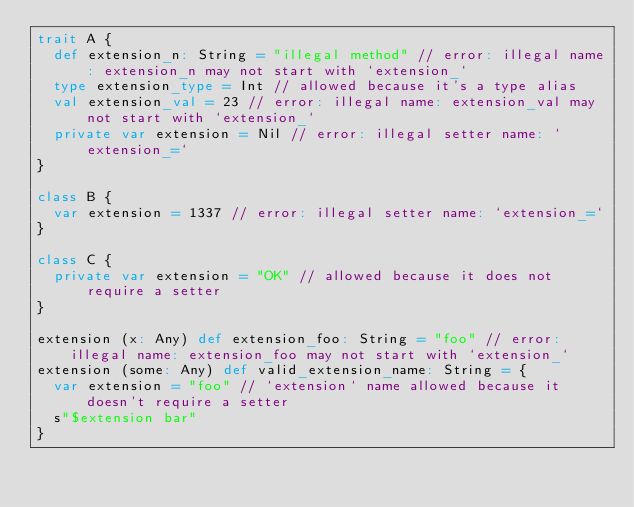<code> <loc_0><loc_0><loc_500><loc_500><_Scala_>trait A {
  def extension_n: String = "illegal method" // error: illegal name: extension_n may not start with `extension_`
  type extension_type = Int // allowed because it's a type alias
  val extension_val = 23 // error: illegal name: extension_val may not start with `extension_`
  private var extension = Nil // error: illegal setter name: `extension_=`
}

class B {
  var extension = 1337 // error: illegal setter name: `extension_=`
}

class C {
  private var extension = "OK" // allowed because it does not require a setter
}

extension (x: Any) def extension_foo: String = "foo" // error: illegal name: extension_foo may not start with `extension_`
extension (some: Any) def valid_extension_name: String = {
  var extension = "foo" // `extension` name allowed because it doesn't require a setter
  s"$extension bar"
}</code> 